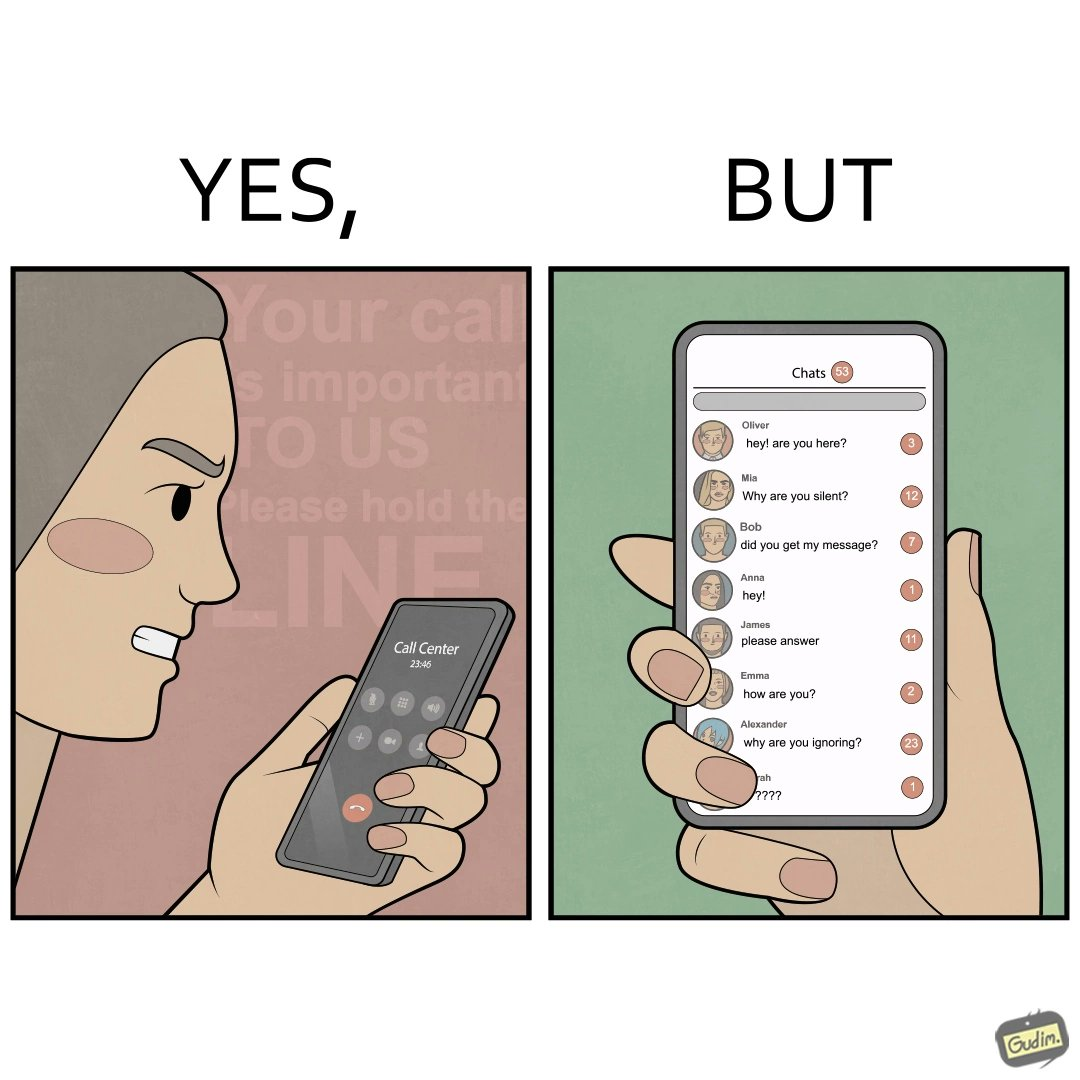Describe the satirical element in this image. The image is ironical because while the woman is annoyed by the unresponsiveness of the call center, she herself is being unresponsive to many people in the chat. 